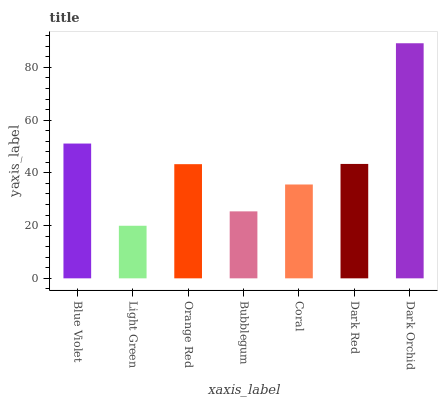Is Light Green the minimum?
Answer yes or no. Yes. Is Dark Orchid the maximum?
Answer yes or no. Yes. Is Orange Red the minimum?
Answer yes or no. No. Is Orange Red the maximum?
Answer yes or no. No. Is Orange Red greater than Light Green?
Answer yes or no. Yes. Is Light Green less than Orange Red?
Answer yes or no. Yes. Is Light Green greater than Orange Red?
Answer yes or no. No. Is Orange Red less than Light Green?
Answer yes or no. No. Is Orange Red the high median?
Answer yes or no. Yes. Is Orange Red the low median?
Answer yes or no. Yes. Is Dark Orchid the high median?
Answer yes or no. No. Is Blue Violet the low median?
Answer yes or no. No. 